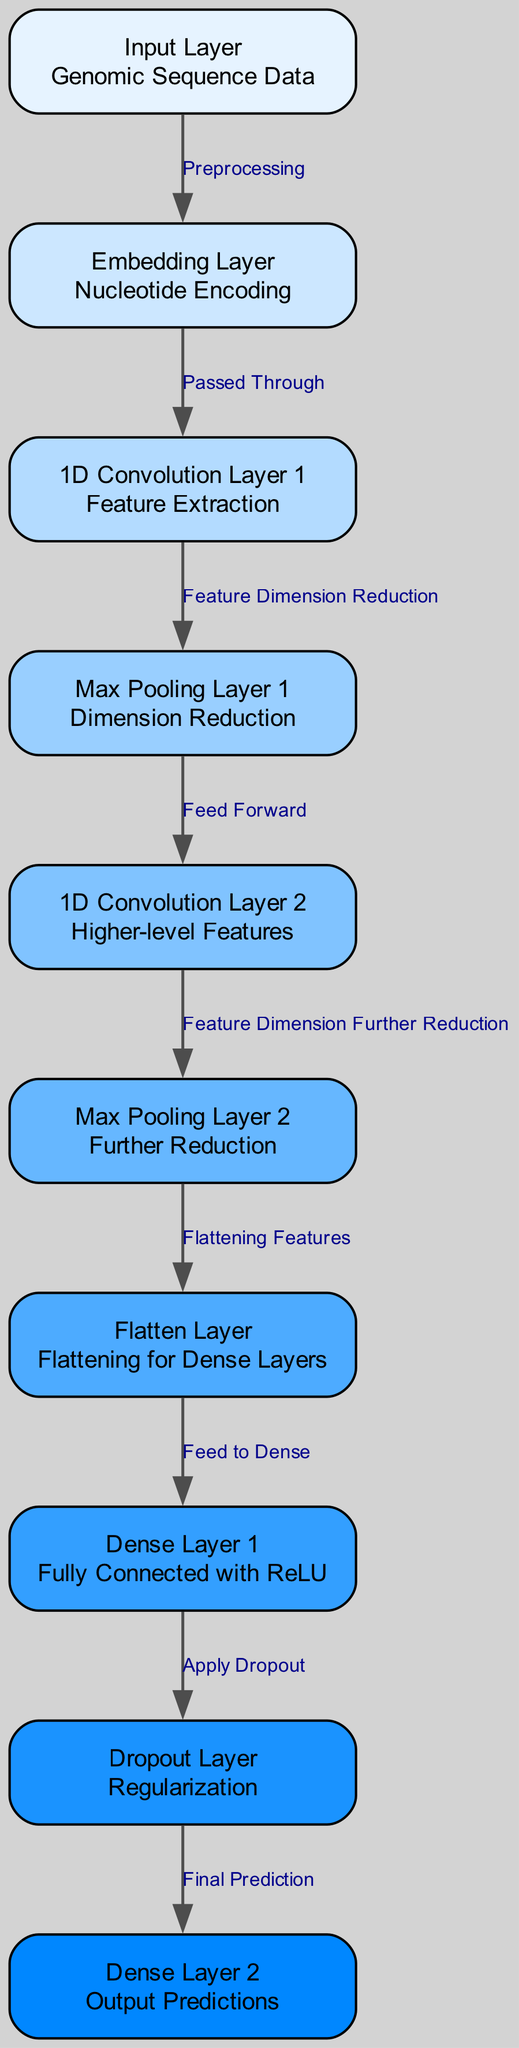What is the first layer in the neural network? The first layer in the diagram is labeled as "Input Layer" which processes the genomic sequence data.
Answer: Input Layer How many layers does this neural network have? Counting the nodes in the diagram, there are ten distinct layers represented from the input layer to the output predictions layer.
Answer: 10 What type of data is represented in the input layer? The description of the input layer states that it processes genomic sequence data as input.
Answer: Genomic Sequence Data What is the function of the dropout layer? The dropout layer is used as a regularization technique to prevent overfitting in the model.
Answer: Regularization How does the max pooling layer contribute to the network? Max pooling layers perform dimension reduction, which helps simplify the model by reducing the number of features while retaining important information.
Answer: Dimension Reduction Which layer follows the first convolution layer? The edge connecting "1D Convolution Layer 1" and "Max Pooling Layer 1" indicates that the next layer after the first convolution layer is the max pooling layer.
Answer: Max Pooling Layer 1 What is the main purpose of the embedding layer? The embedding layer is focused on encoding nucleotide sequences to prepare them for further processing within the neural network.
Answer: Nucleotide Encoding How many convolution layers are present in the architecture? The diagram shows two distinct convolution layers labeled as "1D Convolution Layer 1" and "1D Convolution Layer 2".
Answer: 2 What type of activation function is applied in Dense Layer 1? The description for "Dense Layer 1" specifies that it is a fully connected layer using the ReLU activation function.
Answer: ReLU 